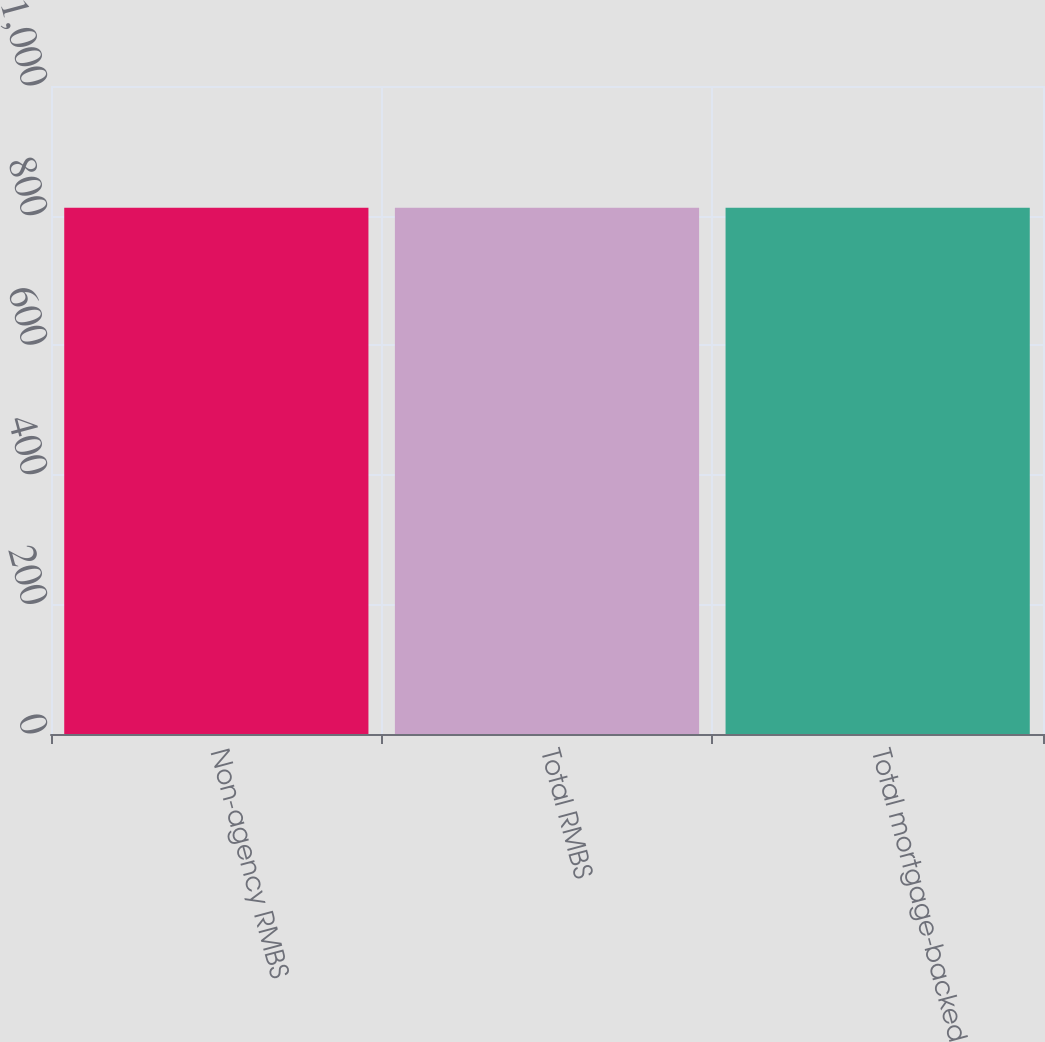<chart> <loc_0><loc_0><loc_500><loc_500><bar_chart><fcel>Non-agency RMBS<fcel>Total RMBS<fcel>Total mortgage-backed<nl><fcel>812<fcel>812.1<fcel>812.2<nl></chart> 